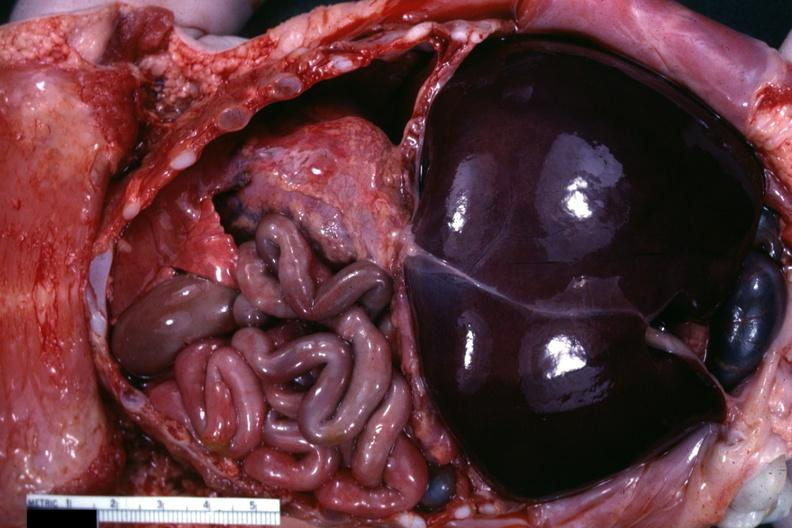what is present?
Answer the question using a single word or phrase. Muscle 